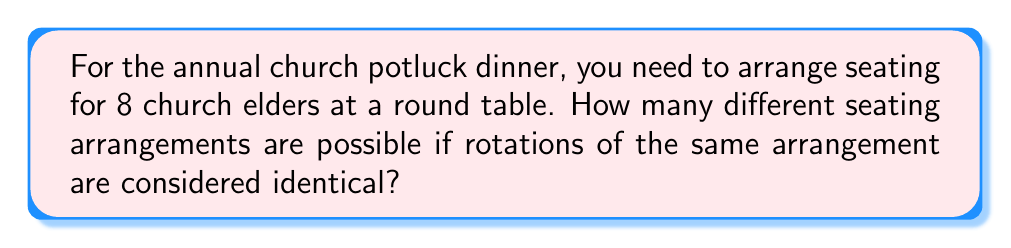Provide a solution to this math problem. Let's approach this step-by-step:

1) First, we need to recognize that this is a circular permutation problem. In a circular arrangement, rotations of the same arrangement are considered identical.

2) For a regular permutation of n distinct objects, we would have n! arrangements.

3) However, in a circular permutation, we consider all rotations of a particular arrangement as the same. There are n rotations possible for each arrangement (including the original arrangement).

4) Therefore, the number of unique circular permutations is (n-1)!

5) In this case, n = 8 (the number of church elders)

6) So, the number of unique seating arrangements is:

   $$(8-1)! = 7!$$

7) Let's calculate this:
   
   $$7! = 7 \times 6 \times 5 \times 4 \times 3 \times 2 \times 1 = 5040$$

Thus, there are 5040 different seating arrangements possible for the 8 church elders at the round table.
Answer: 5040 seating arrangements 